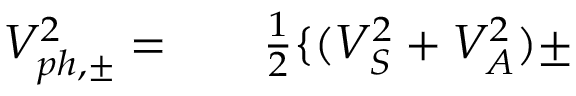<formula> <loc_0><loc_0><loc_500><loc_500>\begin{array} { r l r } { V _ { p h , \pm } ^ { 2 } = } & { \frac { 1 } { 2 } \{ ( V _ { S } ^ { 2 } + V _ { A } ^ { 2 } ) \pm } \end{array}</formula> 